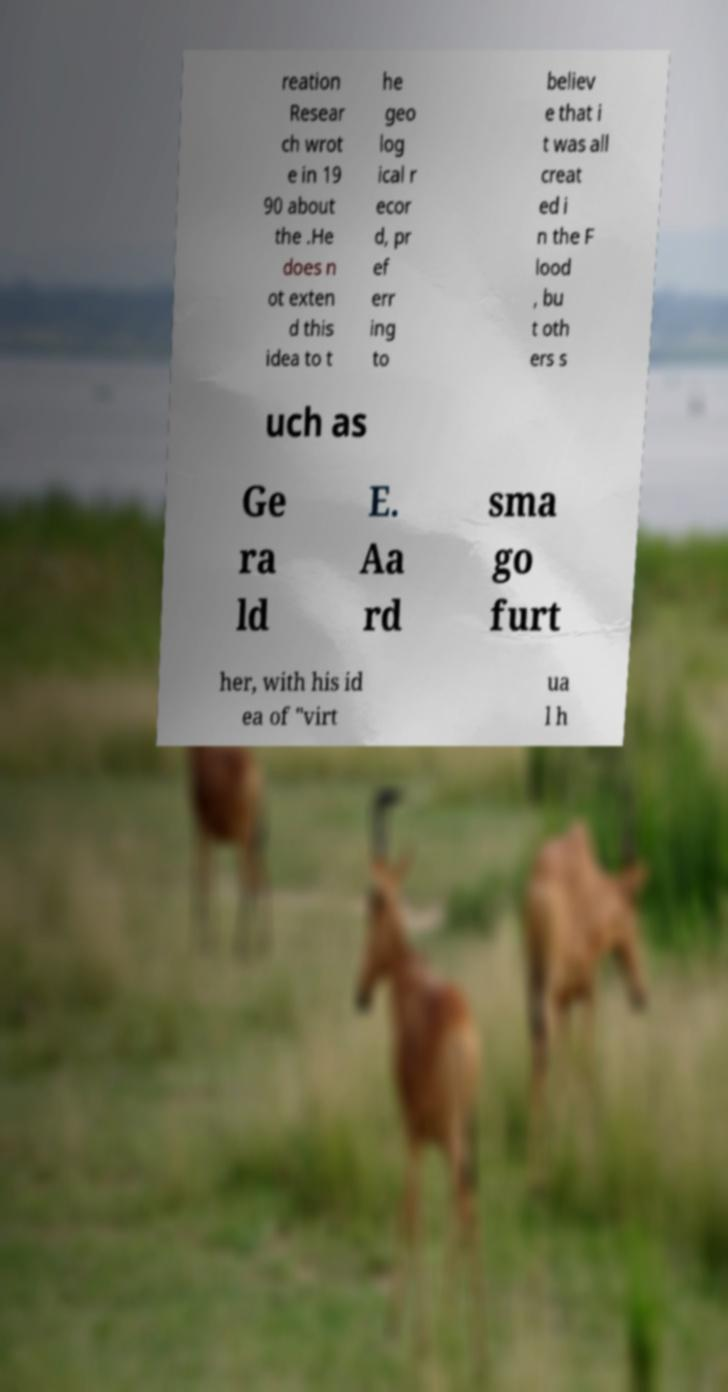What messages or text are displayed in this image? I need them in a readable, typed format. reation Resear ch wrot e in 19 90 about the .He does n ot exten d this idea to t he geo log ical r ecor d, pr ef err ing to believ e that i t was all creat ed i n the F lood , bu t oth ers s uch as Ge ra ld E. Aa rd sma go furt her, with his id ea of "virt ua l h 